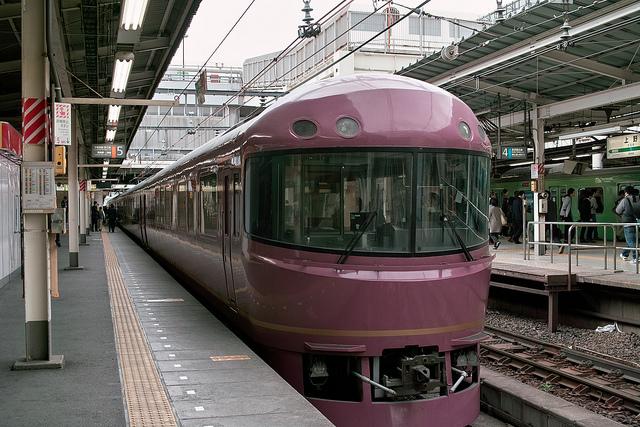Why is the train at platform 5?
Quick response, please. To pick up passengers. Are the lights on the train on?
Short answer required. No. What color is the train?
Answer briefly. Purple. 